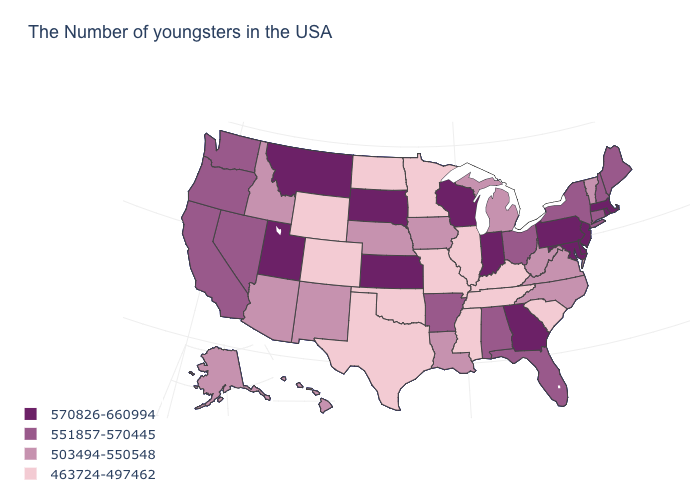What is the highest value in states that border New Jersey?
Give a very brief answer. 570826-660994. Is the legend a continuous bar?
Give a very brief answer. No. Is the legend a continuous bar?
Short answer required. No. Does Rhode Island have the highest value in the Northeast?
Short answer required. Yes. Which states have the lowest value in the USA?
Keep it brief. South Carolina, Kentucky, Tennessee, Illinois, Mississippi, Missouri, Minnesota, Oklahoma, Texas, North Dakota, Wyoming, Colorado. What is the value of Wisconsin?
Quick response, please. 570826-660994. Among the states that border Texas , which have the highest value?
Answer briefly. Arkansas. Which states have the highest value in the USA?
Concise answer only. Massachusetts, Rhode Island, New Jersey, Delaware, Maryland, Pennsylvania, Georgia, Indiana, Wisconsin, Kansas, South Dakota, Utah, Montana. What is the highest value in the USA?
Give a very brief answer. 570826-660994. What is the lowest value in the USA?
Give a very brief answer. 463724-497462. What is the value of Louisiana?
Short answer required. 503494-550548. Does the first symbol in the legend represent the smallest category?
Be succinct. No. What is the value of Indiana?
Be succinct. 570826-660994. What is the highest value in states that border Virginia?
Keep it brief. 570826-660994. What is the highest value in states that border Indiana?
Write a very short answer. 551857-570445. 